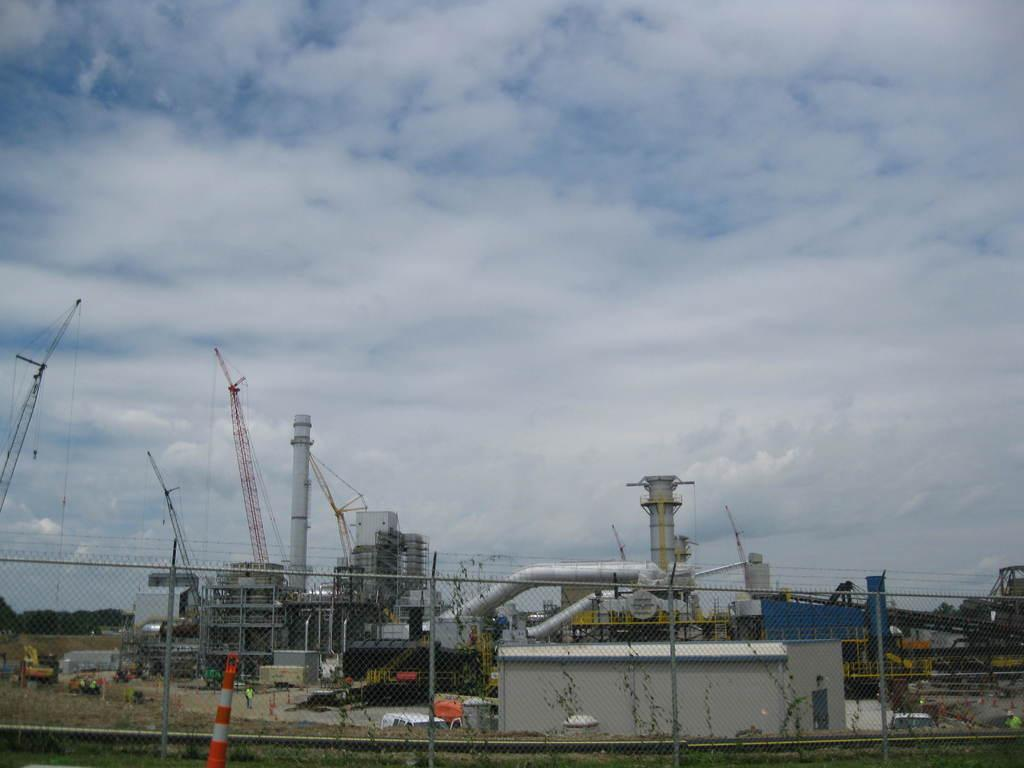What type of structures can be seen in the image? There are buildings, a factory, and a fence in the image. What is the purpose of the pipe in the image? The purpose of the pipe is not specified in the image, but it is likely related to the factory or buildings. What other objects can be seen on the ground in the image? There are poles and other objects on the ground in the image. What can be seen in the background of the image? There are trees and the sky visible in the background of the image. What type of gold can be seen in the image? There is no gold present in the image. What type of engine can be seen in the image? There is no engine present in the image. 